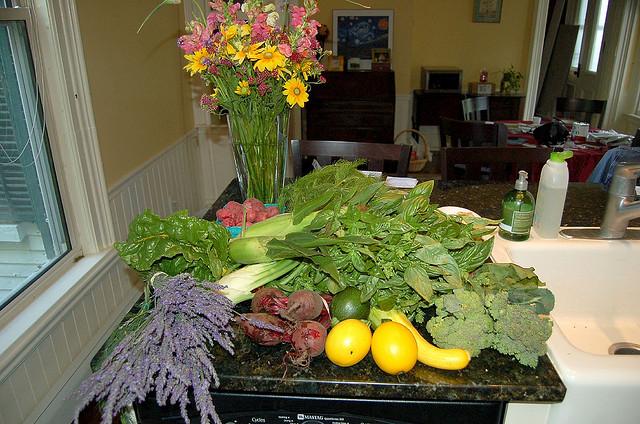What vegetables are displayed?
Short answer required. Squash, broccoli, beets, leeks, kale. Are there any lemons on the table?
Keep it brief. Yes. What are the yellow flowers called in the vase?
Keep it brief. Daisies. What is the largest flower in the vase?
Give a very brief answer. Daisy. Is there a garden outside the window?
Answer briefly. No. What is the name of the painting on the wall?
Write a very short answer. Starry night. 